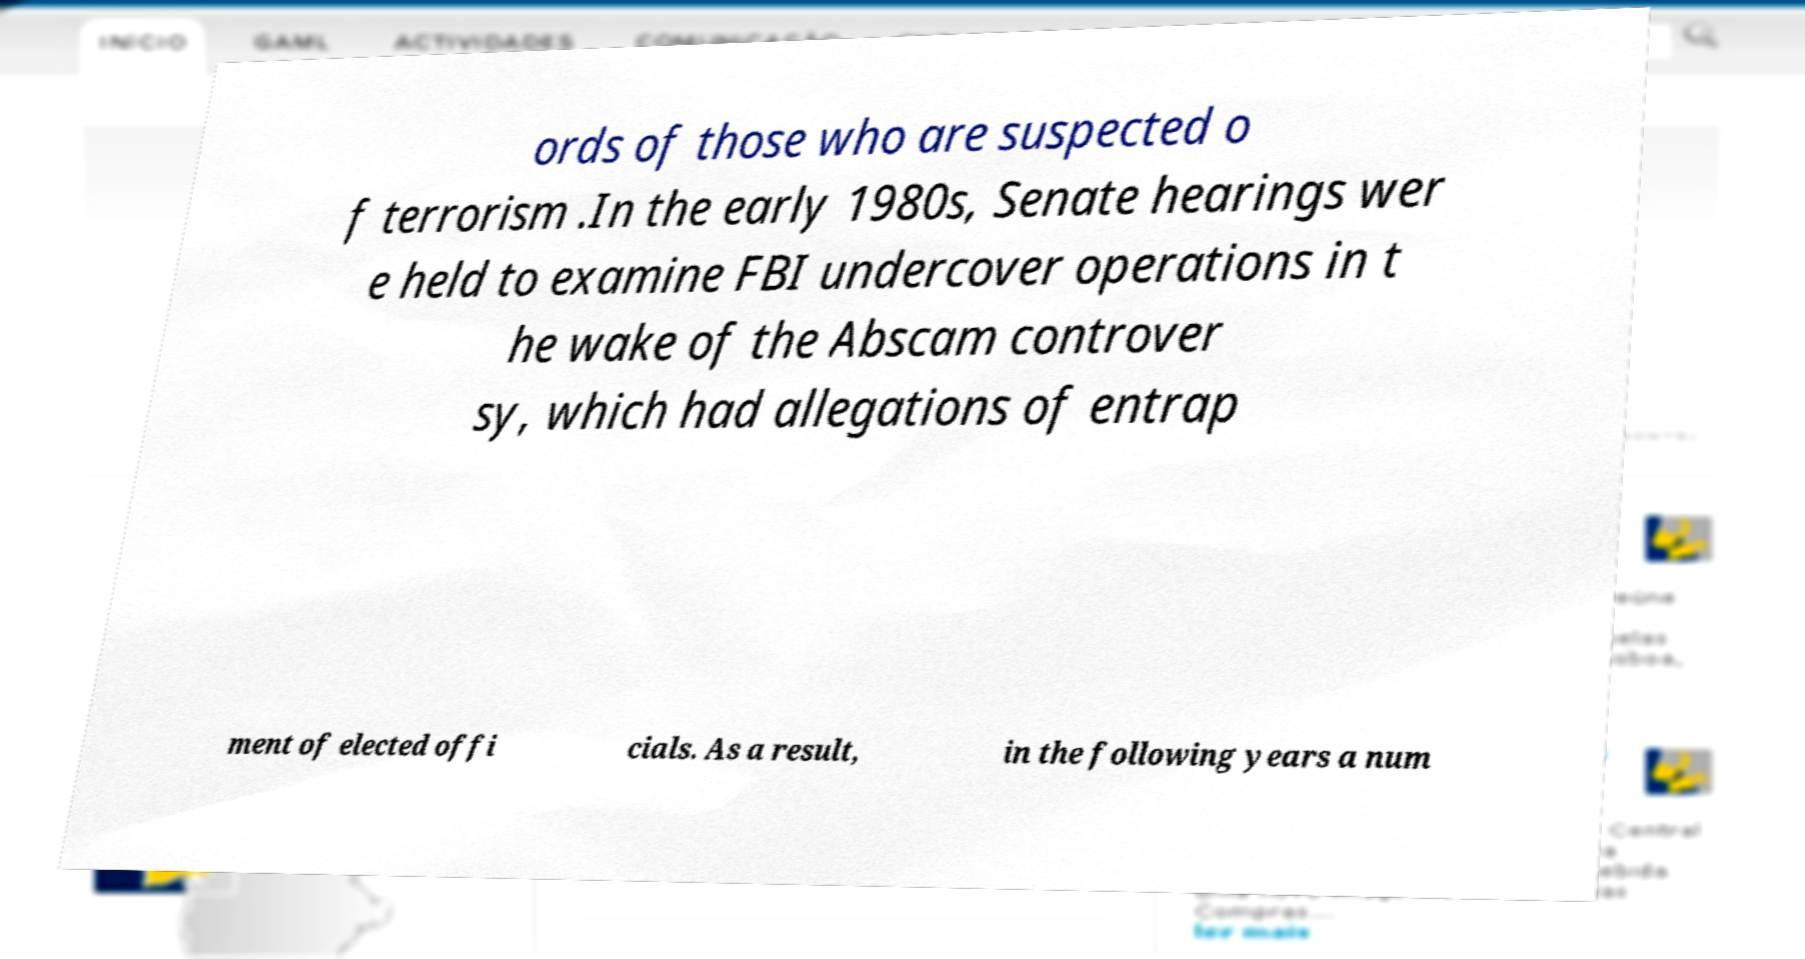Can you accurately transcribe the text from the provided image for me? ords of those who are suspected o f terrorism .In the early 1980s, Senate hearings wer e held to examine FBI undercover operations in t he wake of the Abscam controver sy, which had allegations of entrap ment of elected offi cials. As a result, in the following years a num 